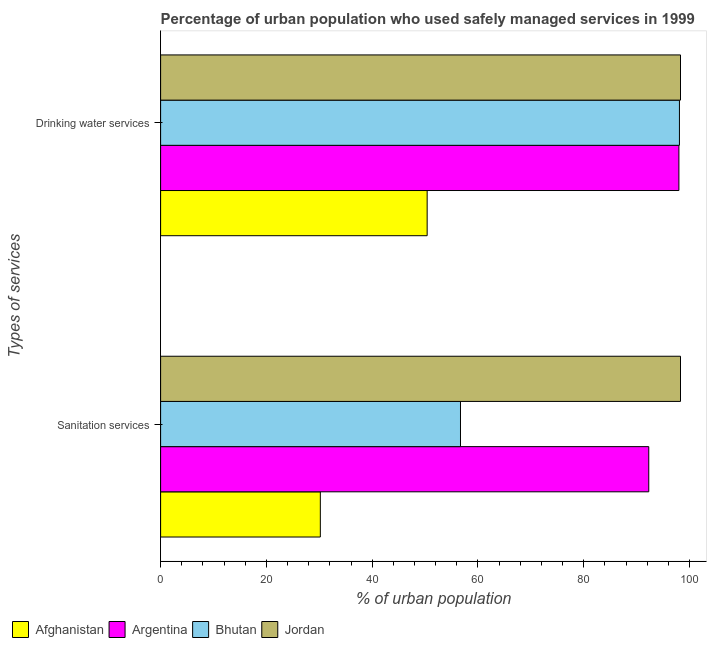How many different coloured bars are there?
Ensure brevity in your answer.  4. How many groups of bars are there?
Provide a succinct answer. 2. Are the number of bars per tick equal to the number of legend labels?
Provide a succinct answer. Yes. How many bars are there on the 1st tick from the top?
Your answer should be compact. 4. How many bars are there on the 2nd tick from the bottom?
Give a very brief answer. 4. What is the label of the 1st group of bars from the top?
Offer a terse response. Drinking water services. What is the percentage of urban population who used sanitation services in Afghanistan?
Offer a very short reply. 30.2. Across all countries, what is the maximum percentage of urban population who used sanitation services?
Make the answer very short. 98.3. Across all countries, what is the minimum percentage of urban population who used sanitation services?
Keep it short and to the point. 30.2. In which country was the percentage of urban population who used drinking water services maximum?
Provide a succinct answer. Jordan. In which country was the percentage of urban population who used sanitation services minimum?
Give a very brief answer. Afghanistan. What is the total percentage of urban population who used drinking water services in the graph?
Offer a very short reply. 344.8. What is the difference between the percentage of urban population who used drinking water services in Argentina and that in Afghanistan?
Offer a very short reply. 47.6. What is the difference between the percentage of urban population who used sanitation services in Jordan and the percentage of urban population who used drinking water services in Argentina?
Your response must be concise. 0.3. What is the average percentage of urban population who used sanitation services per country?
Your answer should be very brief. 69.38. What is the difference between the percentage of urban population who used drinking water services and percentage of urban population who used sanitation services in Argentina?
Ensure brevity in your answer.  5.7. What is the ratio of the percentage of urban population who used sanitation services in Jordan to that in Bhutan?
Make the answer very short. 1.73. What does the 3rd bar from the top in Sanitation services represents?
Provide a succinct answer. Argentina. What does the 3rd bar from the bottom in Drinking water services represents?
Make the answer very short. Bhutan. How many bars are there?
Ensure brevity in your answer.  8. Are all the bars in the graph horizontal?
Offer a very short reply. Yes. Does the graph contain any zero values?
Your response must be concise. No. Where does the legend appear in the graph?
Provide a short and direct response. Bottom left. How are the legend labels stacked?
Offer a very short reply. Horizontal. What is the title of the graph?
Your response must be concise. Percentage of urban population who used safely managed services in 1999. Does "Myanmar" appear as one of the legend labels in the graph?
Give a very brief answer. No. What is the label or title of the X-axis?
Give a very brief answer. % of urban population. What is the label or title of the Y-axis?
Offer a very short reply. Types of services. What is the % of urban population in Afghanistan in Sanitation services?
Your response must be concise. 30.2. What is the % of urban population in Argentina in Sanitation services?
Make the answer very short. 92.3. What is the % of urban population of Bhutan in Sanitation services?
Provide a succinct answer. 56.7. What is the % of urban population in Jordan in Sanitation services?
Your answer should be very brief. 98.3. What is the % of urban population of Afghanistan in Drinking water services?
Your answer should be compact. 50.4. What is the % of urban population in Argentina in Drinking water services?
Your response must be concise. 98. What is the % of urban population in Bhutan in Drinking water services?
Keep it short and to the point. 98.1. What is the % of urban population of Jordan in Drinking water services?
Offer a terse response. 98.3. Across all Types of services, what is the maximum % of urban population in Afghanistan?
Ensure brevity in your answer.  50.4. Across all Types of services, what is the maximum % of urban population in Bhutan?
Offer a very short reply. 98.1. Across all Types of services, what is the maximum % of urban population of Jordan?
Ensure brevity in your answer.  98.3. Across all Types of services, what is the minimum % of urban population of Afghanistan?
Provide a succinct answer. 30.2. Across all Types of services, what is the minimum % of urban population in Argentina?
Your answer should be compact. 92.3. Across all Types of services, what is the minimum % of urban population in Bhutan?
Offer a very short reply. 56.7. Across all Types of services, what is the minimum % of urban population in Jordan?
Your response must be concise. 98.3. What is the total % of urban population in Afghanistan in the graph?
Keep it short and to the point. 80.6. What is the total % of urban population in Argentina in the graph?
Keep it short and to the point. 190.3. What is the total % of urban population of Bhutan in the graph?
Your answer should be compact. 154.8. What is the total % of urban population in Jordan in the graph?
Provide a succinct answer. 196.6. What is the difference between the % of urban population of Afghanistan in Sanitation services and that in Drinking water services?
Offer a terse response. -20.2. What is the difference between the % of urban population in Argentina in Sanitation services and that in Drinking water services?
Your answer should be very brief. -5.7. What is the difference between the % of urban population of Bhutan in Sanitation services and that in Drinking water services?
Offer a terse response. -41.4. What is the difference between the % of urban population of Afghanistan in Sanitation services and the % of urban population of Argentina in Drinking water services?
Ensure brevity in your answer.  -67.8. What is the difference between the % of urban population in Afghanistan in Sanitation services and the % of urban population in Bhutan in Drinking water services?
Offer a terse response. -67.9. What is the difference between the % of urban population of Afghanistan in Sanitation services and the % of urban population of Jordan in Drinking water services?
Your answer should be compact. -68.1. What is the difference between the % of urban population of Argentina in Sanitation services and the % of urban population of Jordan in Drinking water services?
Provide a short and direct response. -6. What is the difference between the % of urban population of Bhutan in Sanitation services and the % of urban population of Jordan in Drinking water services?
Ensure brevity in your answer.  -41.6. What is the average % of urban population in Afghanistan per Types of services?
Your answer should be very brief. 40.3. What is the average % of urban population in Argentina per Types of services?
Make the answer very short. 95.15. What is the average % of urban population of Bhutan per Types of services?
Provide a short and direct response. 77.4. What is the average % of urban population in Jordan per Types of services?
Offer a very short reply. 98.3. What is the difference between the % of urban population of Afghanistan and % of urban population of Argentina in Sanitation services?
Make the answer very short. -62.1. What is the difference between the % of urban population of Afghanistan and % of urban population of Bhutan in Sanitation services?
Offer a terse response. -26.5. What is the difference between the % of urban population in Afghanistan and % of urban population in Jordan in Sanitation services?
Your answer should be compact. -68.1. What is the difference between the % of urban population of Argentina and % of urban population of Bhutan in Sanitation services?
Your answer should be compact. 35.6. What is the difference between the % of urban population of Bhutan and % of urban population of Jordan in Sanitation services?
Offer a terse response. -41.6. What is the difference between the % of urban population in Afghanistan and % of urban population in Argentina in Drinking water services?
Provide a short and direct response. -47.6. What is the difference between the % of urban population of Afghanistan and % of urban population of Bhutan in Drinking water services?
Keep it short and to the point. -47.7. What is the difference between the % of urban population of Afghanistan and % of urban population of Jordan in Drinking water services?
Your response must be concise. -47.9. What is the ratio of the % of urban population in Afghanistan in Sanitation services to that in Drinking water services?
Offer a terse response. 0.6. What is the ratio of the % of urban population in Argentina in Sanitation services to that in Drinking water services?
Your answer should be very brief. 0.94. What is the ratio of the % of urban population of Bhutan in Sanitation services to that in Drinking water services?
Offer a terse response. 0.58. What is the ratio of the % of urban population in Jordan in Sanitation services to that in Drinking water services?
Give a very brief answer. 1. What is the difference between the highest and the second highest % of urban population of Afghanistan?
Give a very brief answer. 20.2. What is the difference between the highest and the second highest % of urban population in Argentina?
Offer a terse response. 5.7. What is the difference between the highest and the second highest % of urban population of Bhutan?
Make the answer very short. 41.4. What is the difference between the highest and the second highest % of urban population of Jordan?
Offer a terse response. 0. What is the difference between the highest and the lowest % of urban population in Afghanistan?
Give a very brief answer. 20.2. What is the difference between the highest and the lowest % of urban population in Bhutan?
Provide a succinct answer. 41.4. 